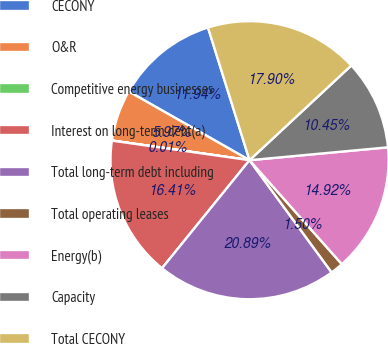<chart> <loc_0><loc_0><loc_500><loc_500><pie_chart><fcel>CECONY<fcel>O&R<fcel>Competitive energy businesses<fcel>Interest on long-term debt(a)<fcel>Total long-term debt including<fcel>Total operating leases<fcel>Energy(b)<fcel>Capacity<fcel>Total CECONY<nl><fcel>11.94%<fcel>5.97%<fcel>0.01%<fcel>16.41%<fcel>20.89%<fcel>1.5%<fcel>14.92%<fcel>10.45%<fcel>17.9%<nl></chart> 